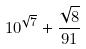<formula> <loc_0><loc_0><loc_500><loc_500>1 0 ^ { \sqrt { 7 } } + \frac { \sqrt { 8 } } { 9 1 }</formula> 